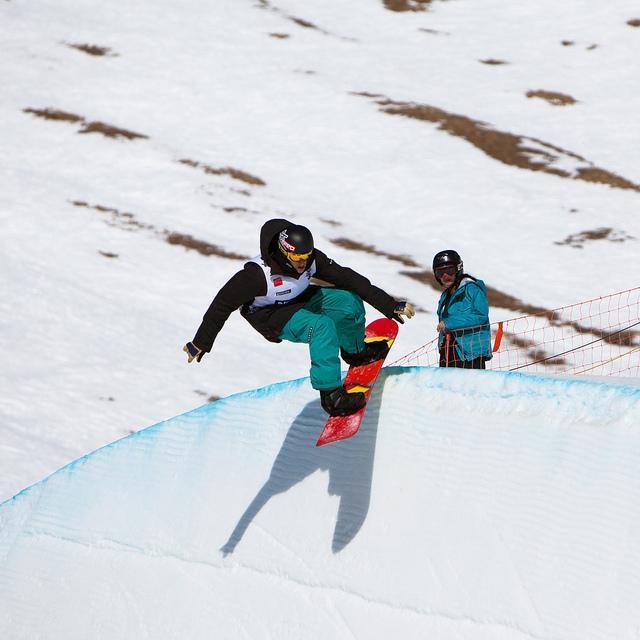How many people are in the picture?
Give a very brief answer. 2. How many people are there?
Give a very brief answer. 2. How many bus on the road?
Give a very brief answer. 0. 